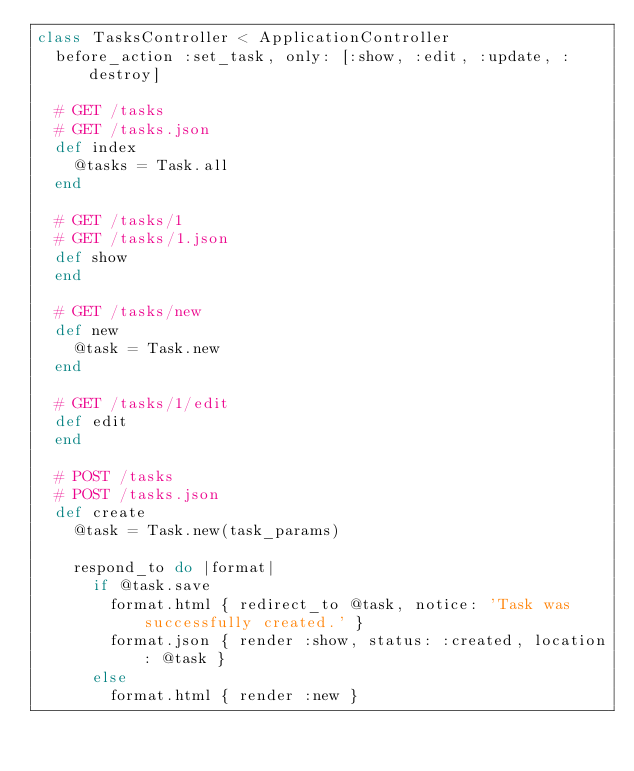Convert code to text. <code><loc_0><loc_0><loc_500><loc_500><_Ruby_>class TasksController < ApplicationController
  before_action :set_task, only: [:show, :edit, :update, :destroy]

  # GET /tasks
  # GET /tasks.json
  def index
    @tasks = Task.all
  end

  # GET /tasks/1
  # GET /tasks/1.json
  def show
  end

  # GET /tasks/new
  def new
    @task = Task.new
  end

  # GET /tasks/1/edit
  def edit
  end

  # POST /tasks
  # POST /tasks.json
  def create
    @task = Task.new(task_params)

    respond_to do |format|
      if @task.save
        format.html { redirect_to @task, notice: 'Task was successfully created.' }
        format.json { render :show, status: :created, location: @task }
      else
        format.html { render :new }</code> 